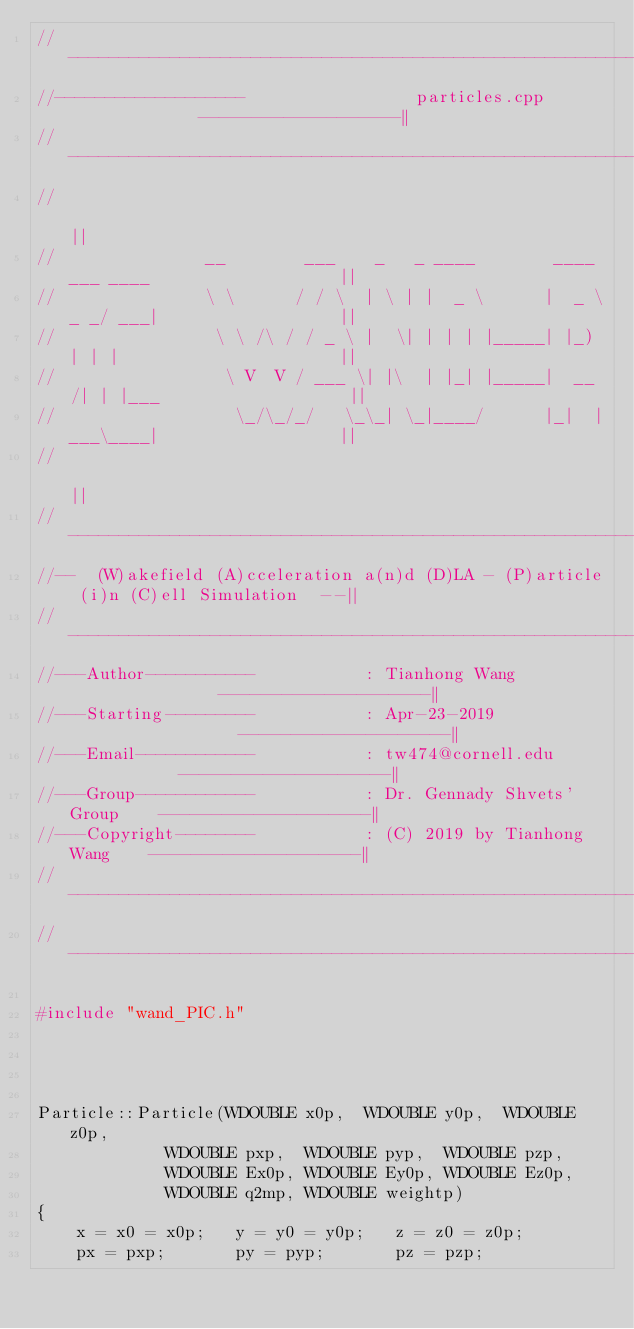<code> <loc_0><loc_0><loc_500><loc_500><_C++_>//----------------------------------------------------------------------------------||
//-------------------                 particles.cpp              -------------------||
//----------------------------------------------------------------------------------||
//                                                                                  ||
//               __        ___    _   _ ____        ____ ___ ____                   ||
//               \ \      / / \  | \ | |  _ \      |  _ \_ _/ ___|                  ||
//                \ \ /\ / / _ \ |  \| | | | |_____| |_) | | |                      ||
//                 \ V  V / ___ \| |\  | |_| |_____|  __/| | |___                   ||
//                  \_/\_/_/   \_\_| \_|____/      |_|  |___\____|                  ||
//                                                                                  ||
//----------------------------------------------------------------------------------||
//--  (W)akefield (A)cceleration a(n)d (D)LA - (P)article (i)n (C)ell Simulation  --||
//----------------------------------------------------------------------------------||
//---Author-----------           : Tianhong Wang                --------------------||
//---Starting---------           : Apr-23-2019                  --------------------||
//---Email------------           : tw474@cornell.edu            --------------------||
//---Group------------           : Dr. Gennady Shvets' Group    --------------------||
//---Copyright--------           : (C) 2019 by Tianhong Wang    --------------------||
//----------------------------------------------------------------------------------||
//----------------------------------------------------------------------------------||

#include "wand_PIC.h"




Particle::Particle(WDOUBLE x0p,  WDOUBLE y0p,  WDOUBLE z0p,
			 WDOUBLE pxp,  WDOUBLE pyp,  WDOUBLE pzp,
  			 WDOUBLE Ex0p, WDOUBLE Ey0p, WDOUBLE Ez0p,
  			 WDOUBLE q2mp, WDOUBLE weightp)
{
	x = x0 = x0p;	y = y0 = y0p;	z = z0 = z0p;
	px = pxp;		py = pyp;		pz = pzp;</code> 